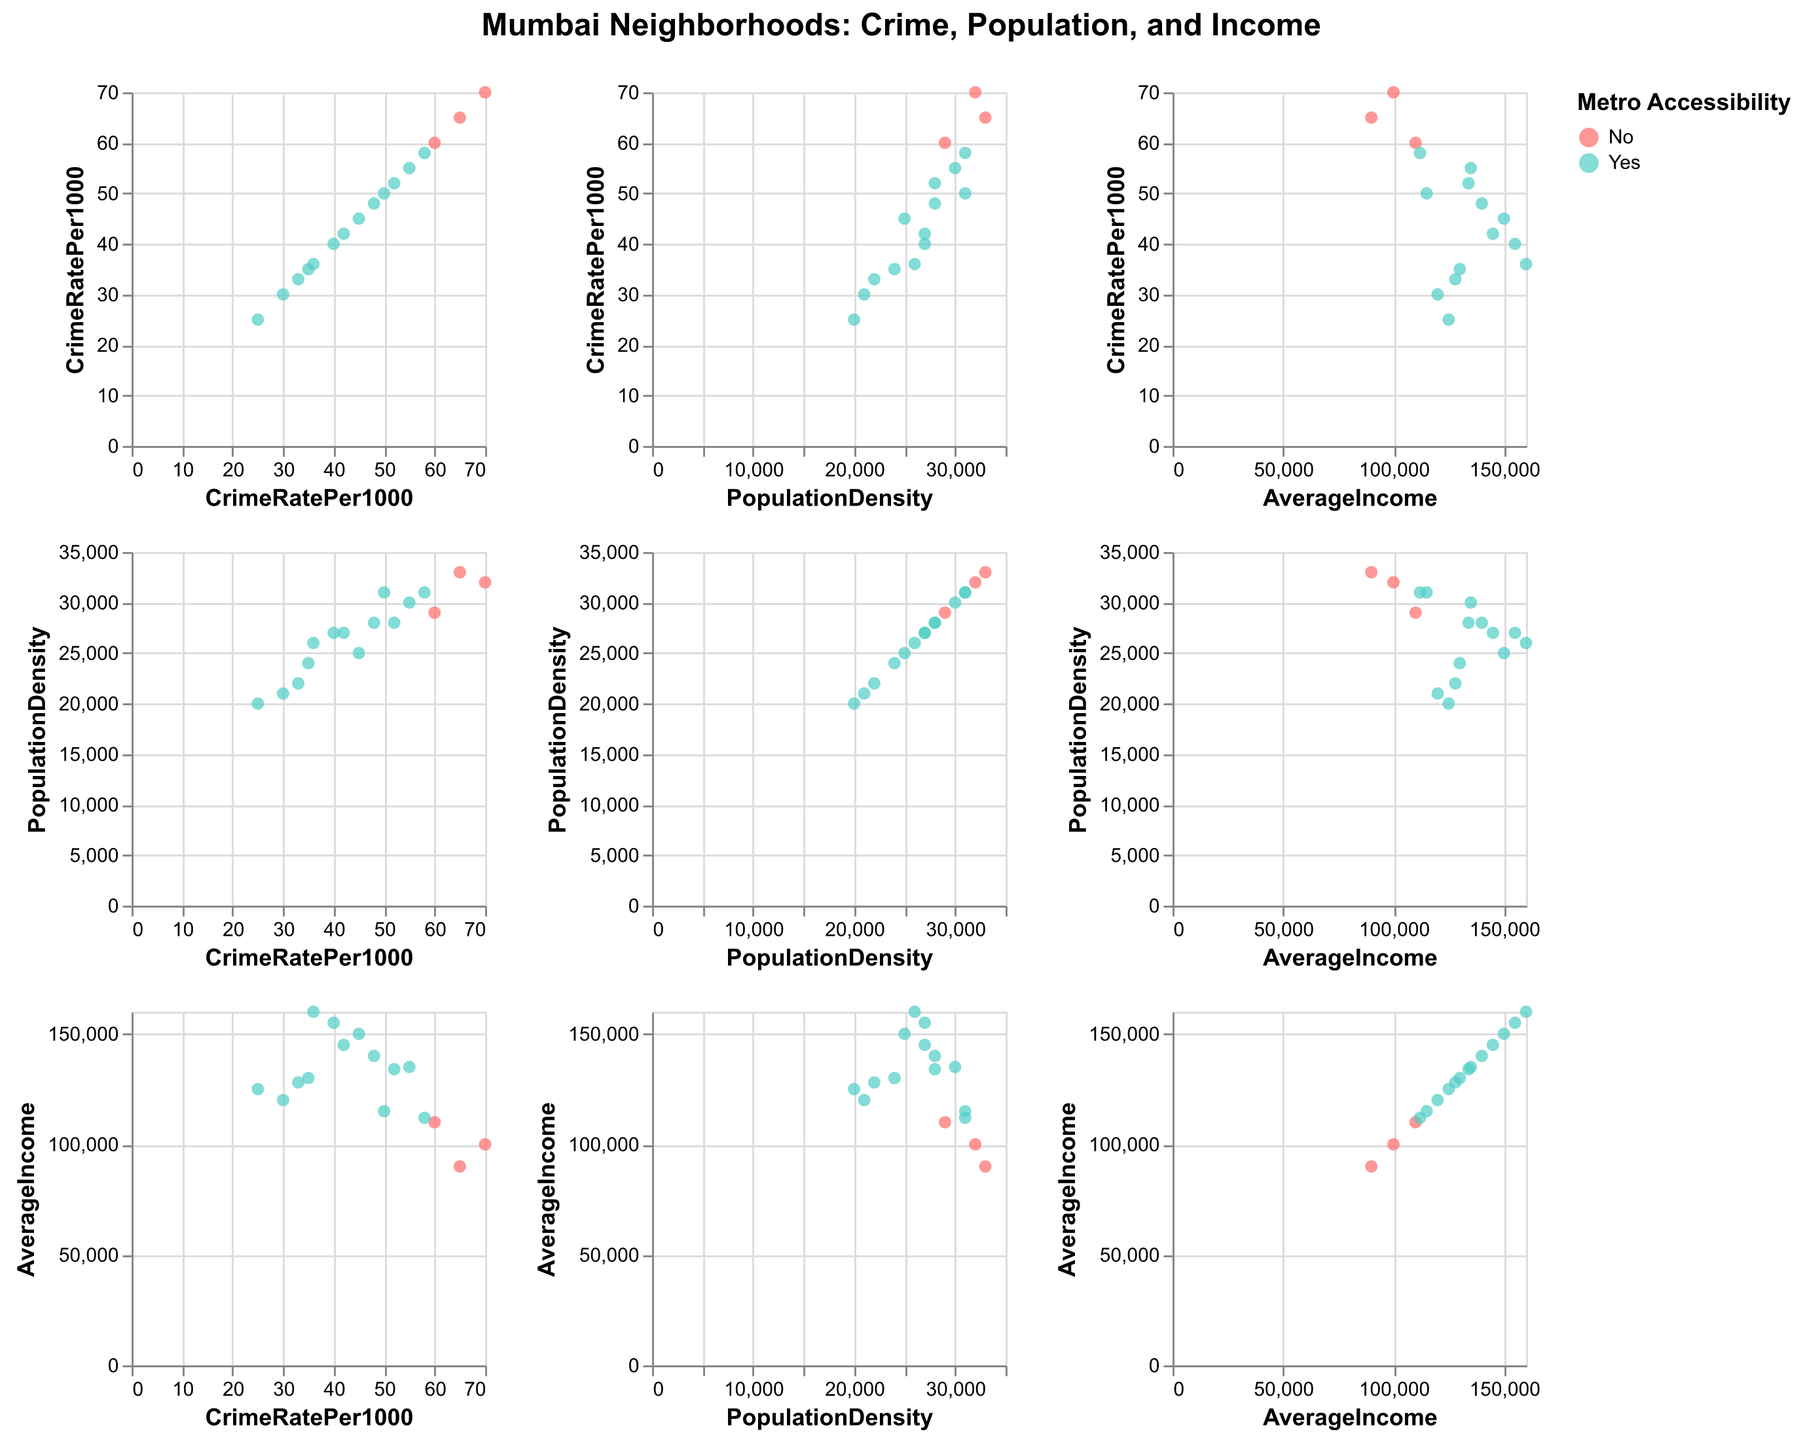Which neighborhood has the lowest crime rate? The SPLOM allows us to compare crime rates across neighborhoods. By scanning the "CrimeRatePer1000" axis, we see that Thane has the lowest crime rate.
Answer: Thane Is there a correlation between population density and crime rate? In the SPLOM, we can look at the scatter plot between "PopulationDensity" and "CrimeRatePer1000". The spread of points does not display a clear linear trend, implying no strong correlation.
Answer: No strong correlation Are neighborhoods with metro accessibility generally occurring at higher or lower crime rates? By identifying neighborhoods with metro accessibility (colored differently) in the crime rate axis, we observe that crime rates vary widely and do not consistently cluster in one range.
Answer: Vary widely Which neighborhood with no metro accessibility has the highest crime rate? Identify neighborhoods with no metro accessibility (specific color) and compare their crime rates. Byculla, Kurla, and Bhiwandi appear, with Kurla having the highest crime rate.
Answer: Kurla What is the average income of neighborhoods with the highest crime rate above 60 per 1000? Filter neighborhoods with crime rates above 60 per 1000 (Byculla, Kurla, Bhiwandi). Their incomes are 110000, 100000, and 90000, respectively. Calculate the average as (110000 + 100000 + 90000)/3.
Answer: 100000 Which has more data points, metro-accessible neighborhoods or non-metro-accessible ones? Count the data points for each group by visual inspection of color groups representing metro accessibility. Metro-accessible has more data points.
Answer: Metro-accessible Do higher-income neighborhoods (>140000) have lower crime rates? Locate neighborhoods with average income above 140000 and check their crime rates. Colaba, Khar, and Worli are in this category, with crime rates ranging from 36 to 45, not significantly lower.
Answer: Not significantly lower Which two neighborhoods have similar average incomes but different crime rates? By analyzing the average income and crime rates, we find that Colaba and Bandra have similar incomes (150000 and 145000) but crime rates of 45 and 42, respectively.
Answer: Colaba and Bandra 